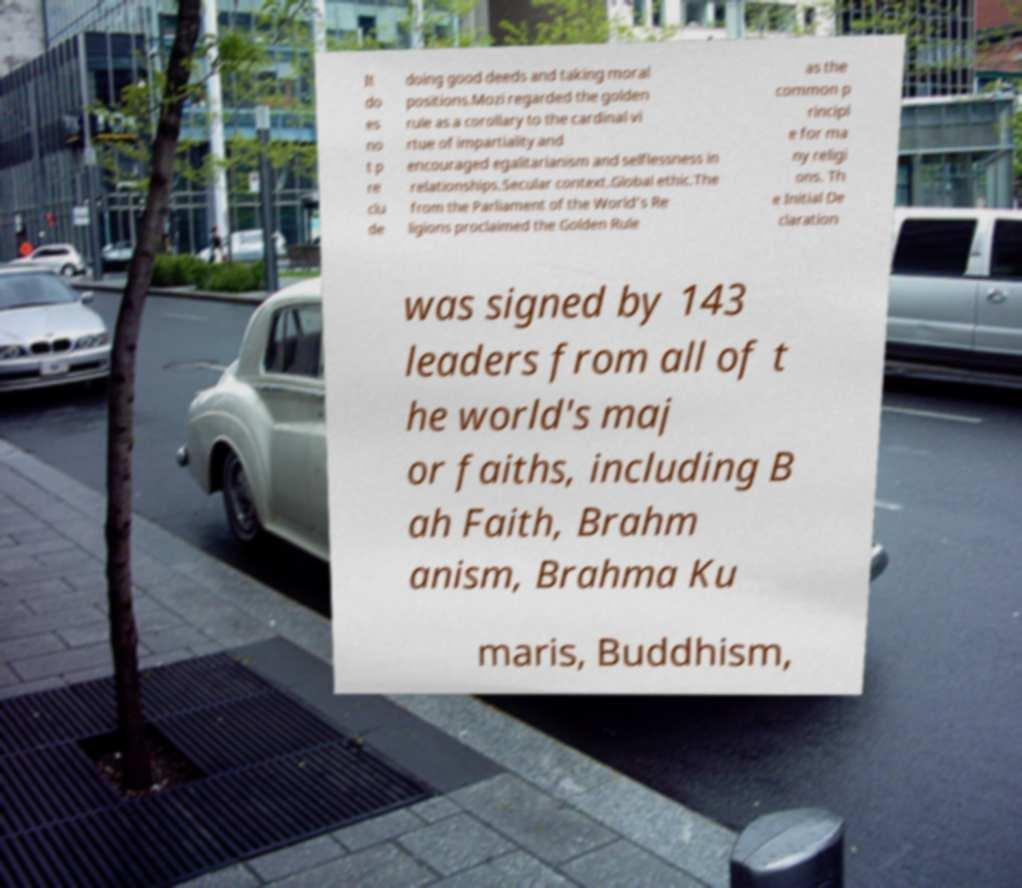For documentation purposes, I need the text within this image transcribed. Could you provide that? It do es no t p re clu de doing good deeds and taking moral positions.Mozi regarded the golden rule as a corollary to the cardinal vi rtue of impartiality and encouraged egalitarianism and selflessness in relationships.Secular context.Global ethic.The from the Parliament of the World’s Re ligions proclaimed the Golden Rule as the common p rincipl e for ma ny religi ons. Th e Initial De claration was signed by 143 leaders from all of t he world's maj or faiths, including B ah Faith, Brahm anism, Brahma Ku maris, Buddhism, 